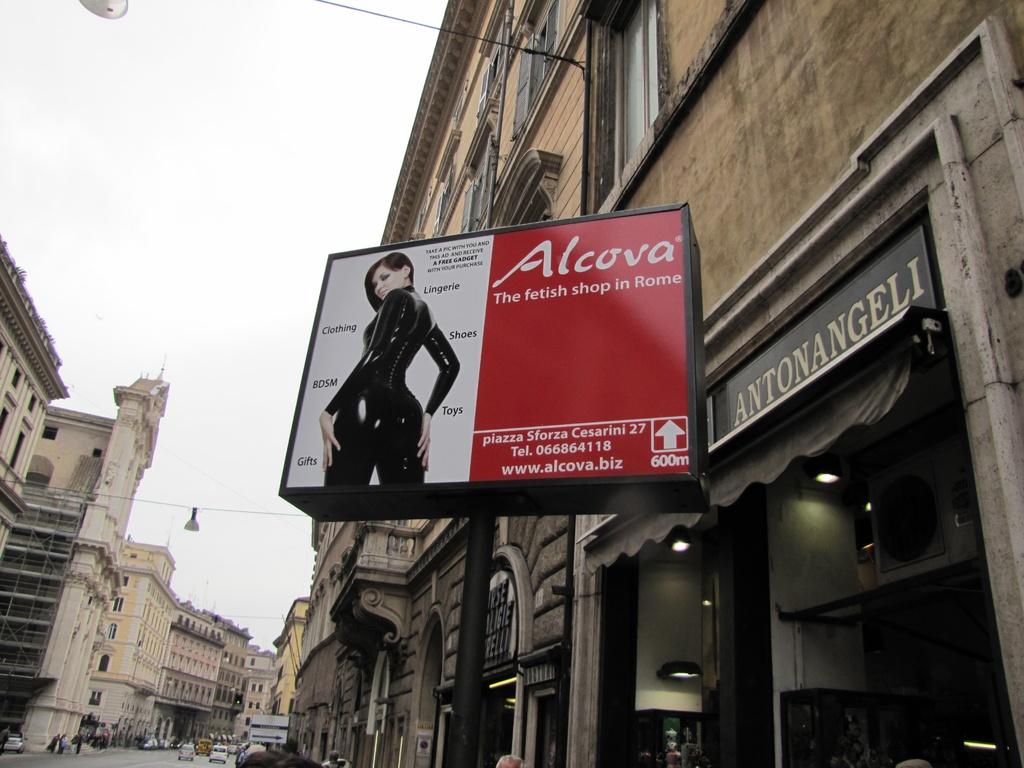What kind of shop is alcova?
Provide a short and direct response. Fetish. What city is this store located in?
Make the answer very short. Rome. 